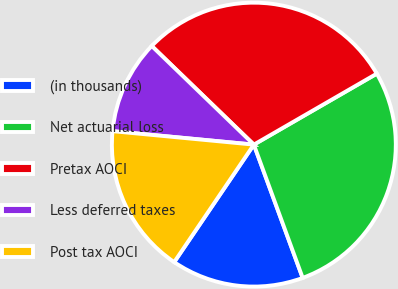Convert chart to OTSL. <chart><loc_0><loc_0><loc_500><loc_500><pie_chart><fcel>(in thousands)<fcel>Net actuarial loss<fcel>Pretax AOCI<fcel>Less deferred taxes<fcel>Post tax AOCI<nl><fcel>15.07%<fcel>27.74%<fcel>29.44%<fcel>10.71%<fcel>17.03%<nl></chart> 